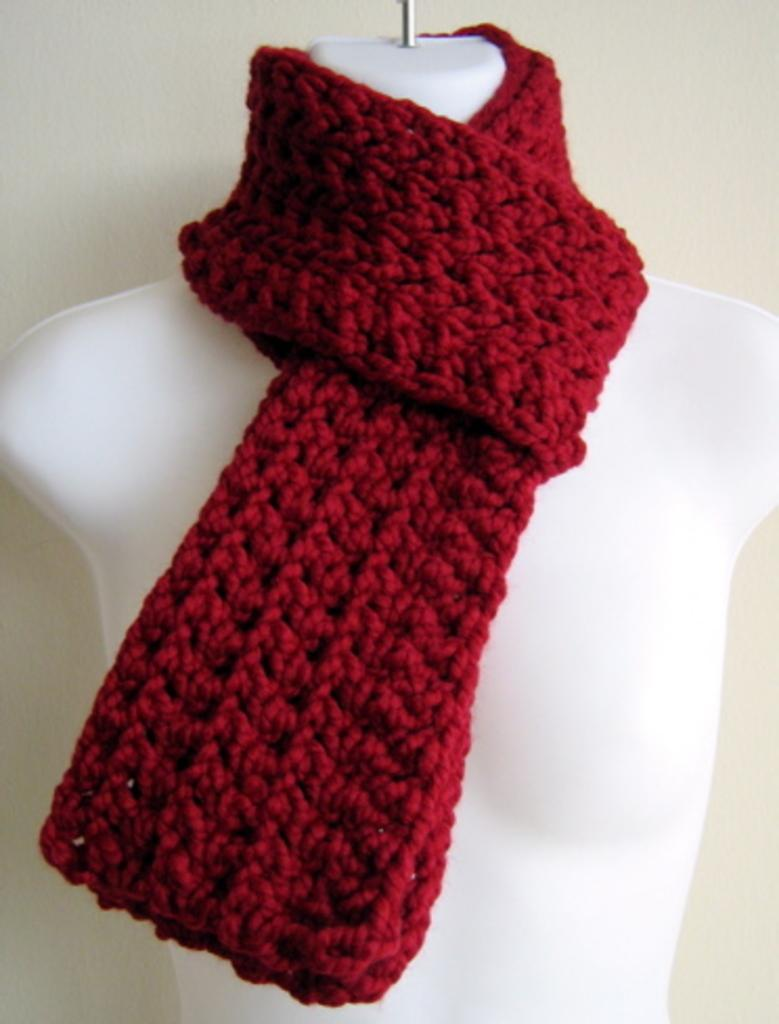What is the main subject in the center of the image? There is a mannequin in the center of the image. What type of clothing item can be seen in the image? There is a red woolen scarf in the image. What can be seen in the background of the image? There is a wall in the background of the image. What type of payment is being offered by the mannequin in the image? There is no payment being offered in the image, as the mannequin is an inanimate object and cannot make offers. 